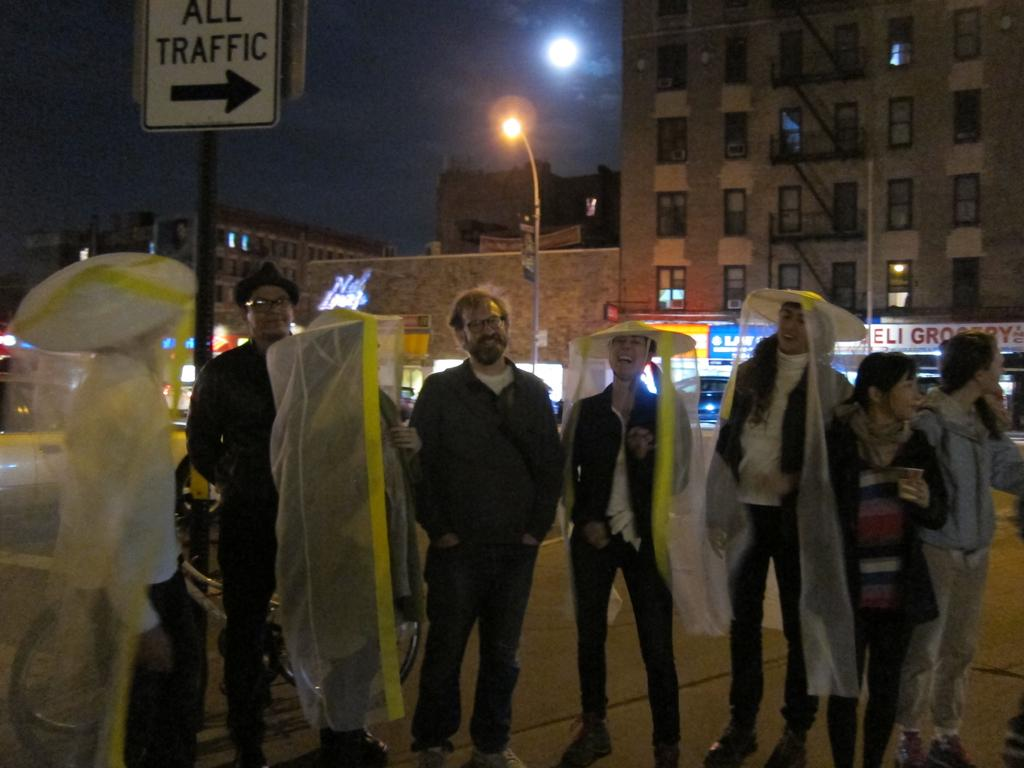What is the main subject of the image? The main subject of the image is a group of people. What are some people in the group wearing? Some people in the group are wearing yellow and white objects. What can be seen in the background of the image? There are buildings in the background of the image. What type of tool is being used by the man in the image? There is no man or tool present in the image; it features a group of people. 